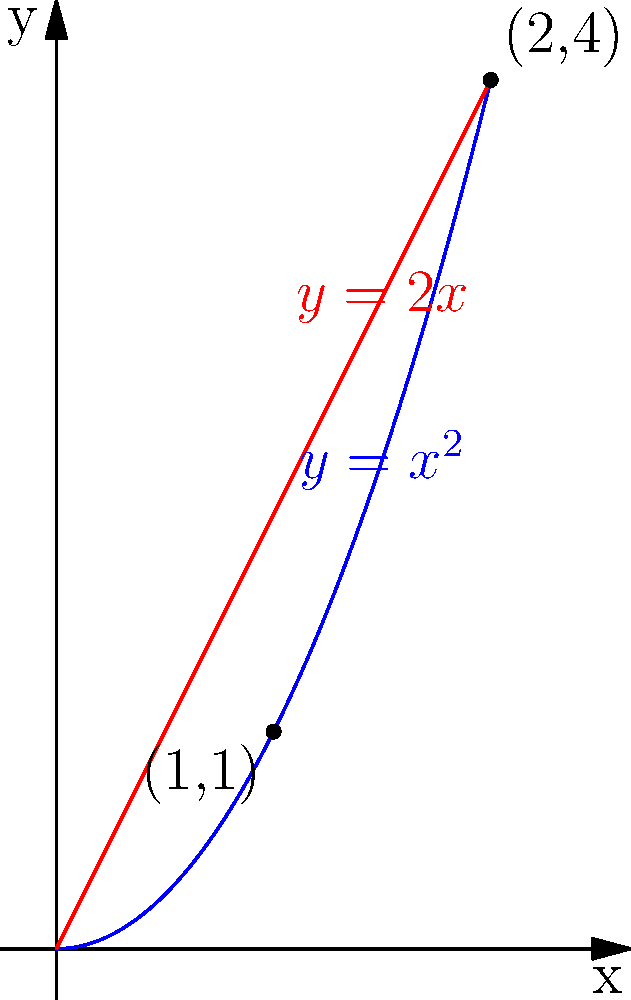As a high school teacher preparing students for university-level calculus, you want to challenge them with a problem involving the area between two intersecting curves. Consider the graph shown above, where the blue curve represents $y=x^2$ and the red line represents $y=2x$. Calculate the area of the region bounded by these two curves. To find the area between two intersecting curves, we follow these steps:

1) First, we need to find the points of intersection. We can do this by setting the equations equal to each other:

   $x^2 = 2x$
   $x^2 - 2x = 0$
   $x(x - 2) = 0$
   $x = 0$ or $x = 2$

   The curves intersect at (0,0) and (2,4).

2) The area between the curves is given by the integral of the difference between the upper and lower functions from the leftmost to the rightmost intersection point:

   $A = \int_{0}^{2} (2x - x^2) dx$

3) Let's evaluate this integral:

   $A = \int_{0}^{2} (2x - x^2) dx$
   $= [x^2 - \frac{1}{3}x^3]_{0}^{2}$
   $= [(2)^2 - \frac{1}{3}(2)^3] - [0^2 - \frac{1}{3}(0)^3]$
   $= [4 - \frac{8}{3}] - [0]$
   $= 4 - \frac{8}{3}$
   $= \frac{12}{3} - \frac{8}{3}$
   $= \frac{4}{3}$

Therefore, the area between the curves is $\frac{4}{3}$ square units.
Answer: $\frac{4}{3}$ square units 